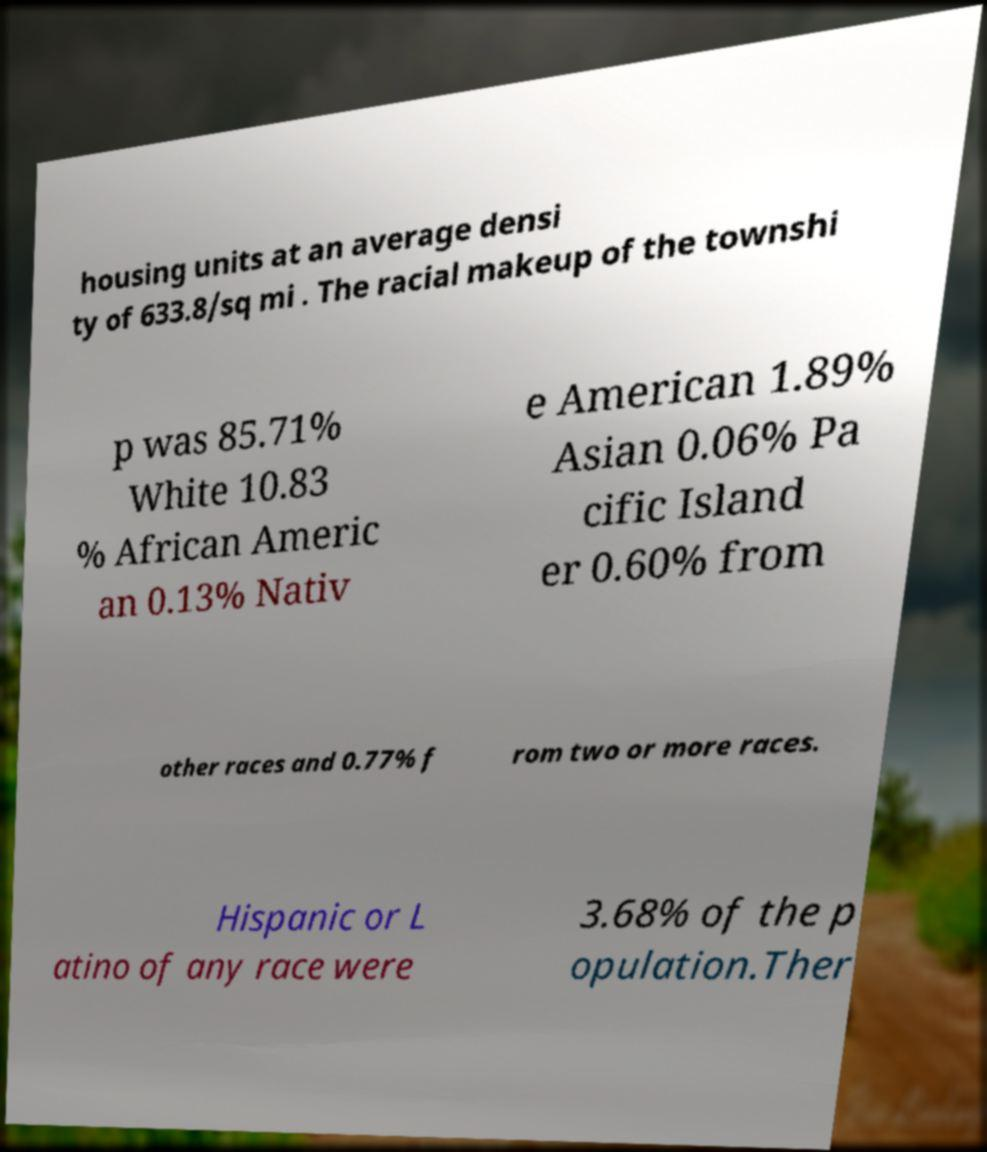What messages or text are displayed in this image? I need them in a readable, typed format. housing units at an average densi ty of 633.8/sq mi . The racial makeup of the townshi p was 85.71% White 10.83 % African Americ an 0.13% Nativ e American 1.89% Asian 0.06% Pa cific Island er 0.60% from other races and 0.77% f rom two or more races. Hispanic or L atino of any race were 3.68% of the p opulation.Ther 